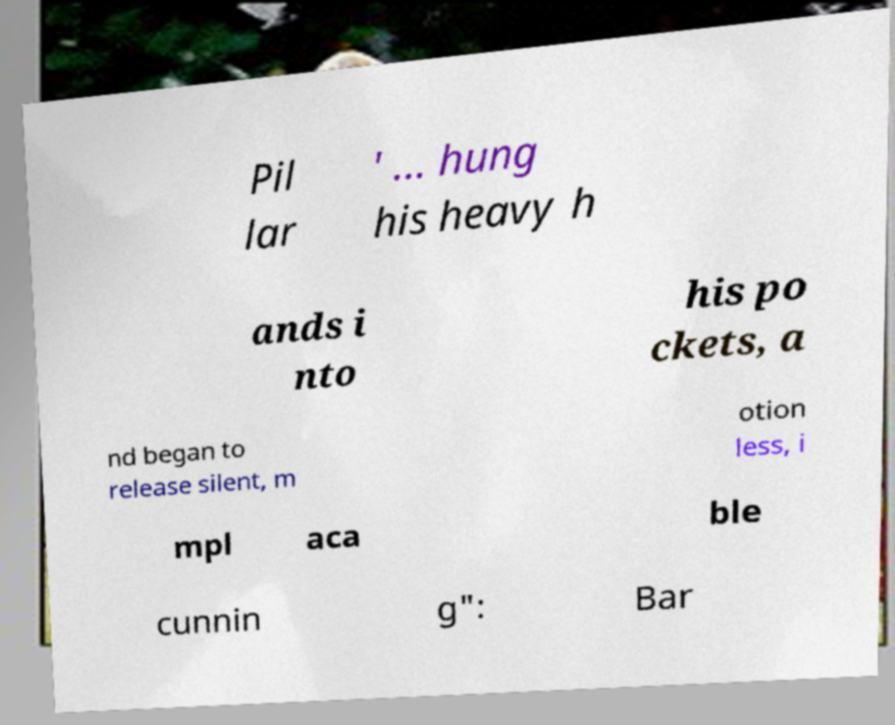I need the written content from this picture converted into text. Can you do that? Pil lar ' ... hung his heavy h ands i nto his po ckets, a nd began to release silent, m otion less, i mpl aca ble cunnin g": Bar 